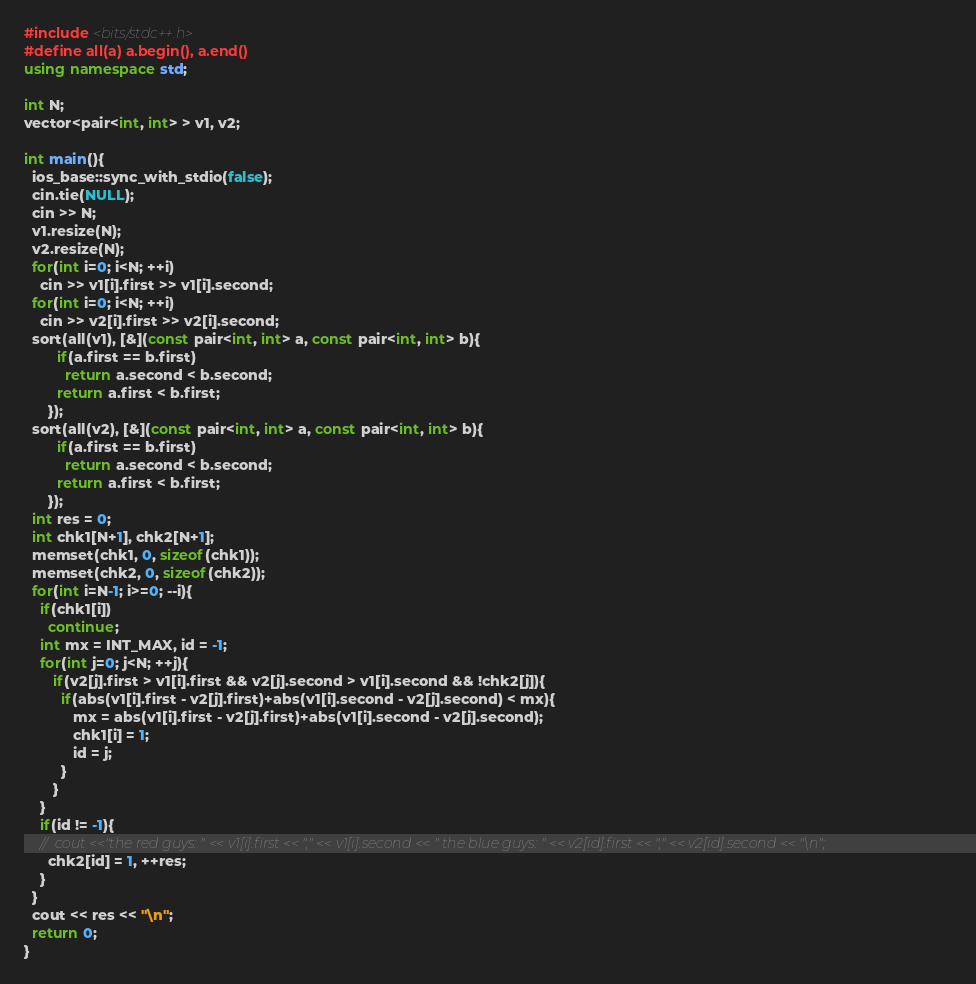<code> <loc_0><loc_0><loc_500><loc_500><_C++_>#include <bits/stdc++.h>
#define all(a) a.begin(), a.end()
using namespace std;
 
int N;
vector<pair<int, int> > v1, v2;

int main(){
  ios_base::sync_with_stdio(false);
  cin.tie(NULL);
  cin >> N;
  v1.resize(N);
  v2.resize(N);
  for(int i=0; i<N; ++i)
    cin >> v1[i].first >> v1[i].second;
  for(int i=0; i<N; ++i)
    cin >> v2[i].first >> v2[i].second;
  sort(all(v1), [&](const pair<int, int> a, const pair<int, int> b){
        if(a.first == b.first)
          return a.second < b.second;
        return a.first < b.first;
      });
  sort(all(v2), [&](const pair<int, int> a, const pair<int, int> b){
        if(a.first == b.first)
          return a.second < b.second;
        return a.first < b.first;
      });
  int res = 0;
  int chk1[N+1], chk2[N+1];
  memset(chk1, 0, sizeof(chk1));
  memset(chk2, 0, sizeof(chk2));
  for(int i=N-1; i>=0; --i){
    if(chk1[i])
      continue;
    int mx = INT_MAX, id = -1;
    for(int j=0; j<N; ++j){
       if(v2[j].first > v1[i].first && v2[j].second > v1[i].second && !chk2[j]){
         if(abs(v1[i].first - v2[j].first)+abs(v1[i].second - v2[j].second) < mx){
            mx = abs(v1[i].first - v2[j].first)+abs(v1[i].second - v2[j].second);
            chk1[i] = 1;
            id = j;
         }
       }
    }
    if(id != -1){
    //  cout <<"the red guys: " << v1[i].first << "," << v1[i].second << " the blue guys: " << v2[id].first << "," << v2[id].second << "\n";
      chk2[id] = 1, ++res;
    }
  }
  cout << res << "\n";
  return 0; 
}

</code> 